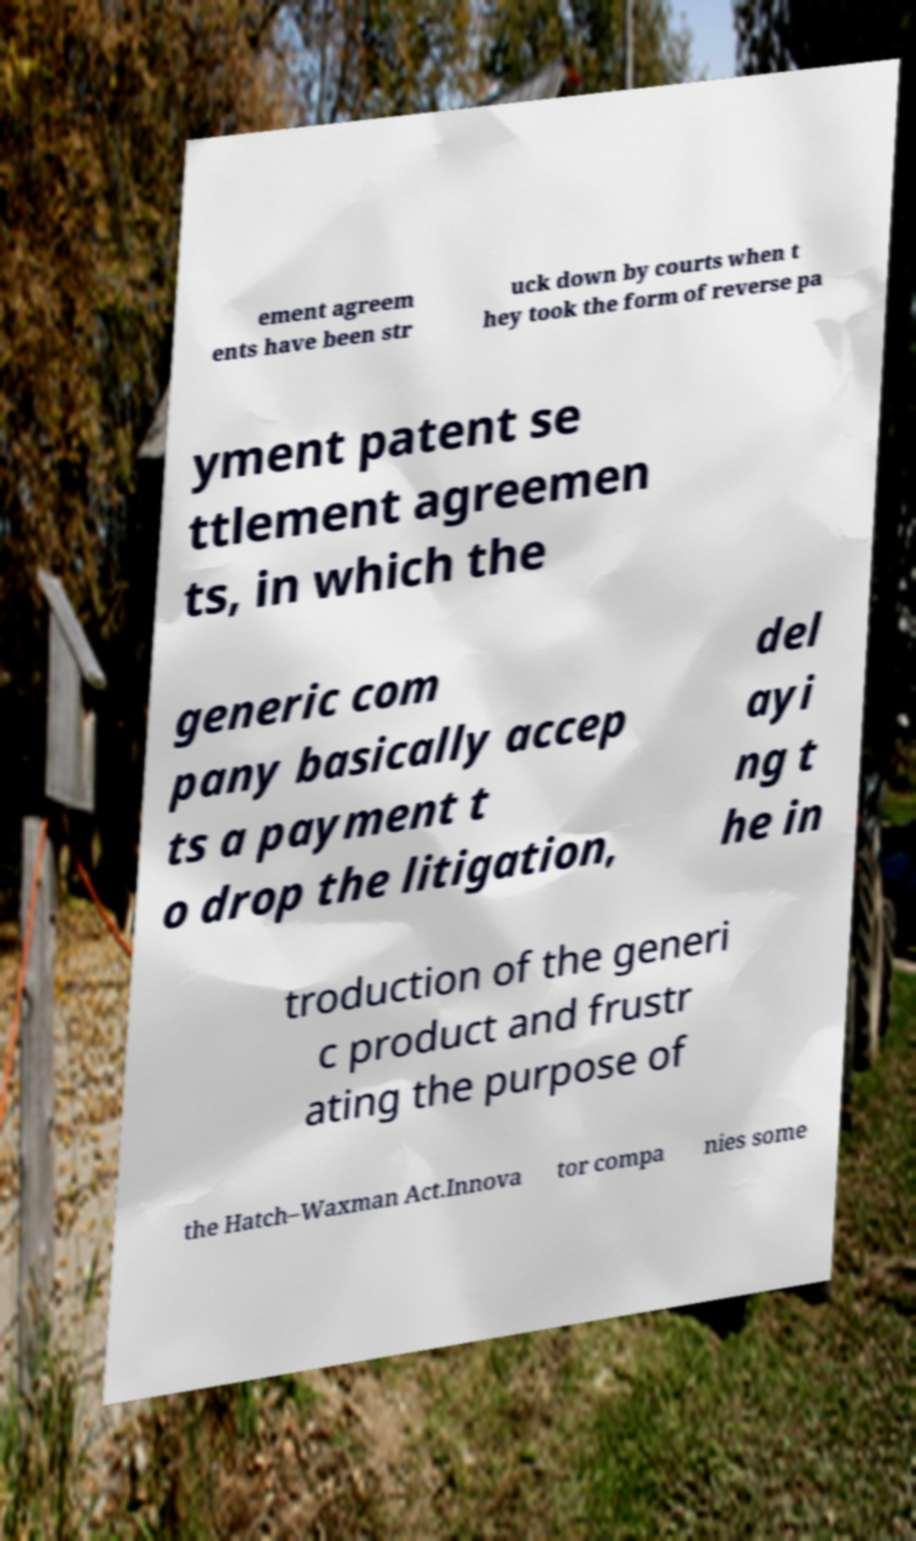Could you extract and type out the text from this image? ement agreem ents have been str uck down by courts when t hey took the form of reverse pa yment patent se ttlement agreemen ts, in which the generic com pany basically accep ts a payment t o drop the litigation, del ayi ng t he in troduction of the generi c product and frustr ating the purpose of the Hatch–Waxman Act.Innova tor compa nies some 